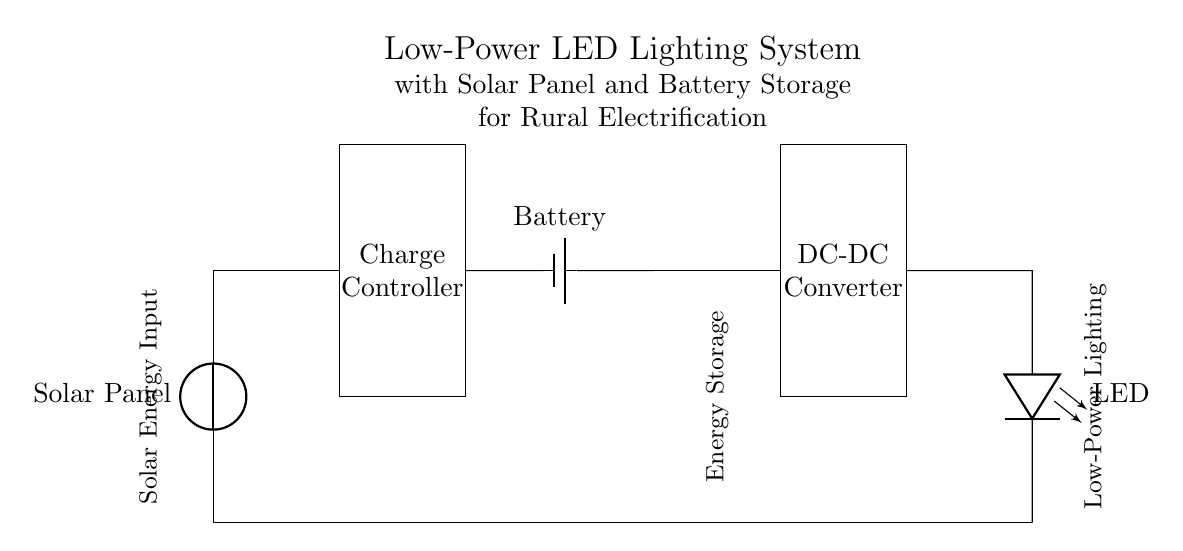What is the primary power source in this circuit? The primary power source in this circuit is the solar panel, which converts solar energy into electrical energy.
Answer: Solar Panel What component is responsible for energy storage? The component responsible for energy storage is the battery, which stores electrical energy generated by the solar panel for later use.
Answer: Battery What type of lighting is used in this system? The type of lighting used in this system is LED, which is energy-efficient and low-power.
Answer: LED How many main components are in the circuit? There are four main components in the circuit: the solar panel, charge controller, battery, and LED.
Answer: Four What functionality does the charge controller provide? The charge controller regulates the voltage and current coming from the solar panel to prevent overcharging the battery and ensure safe operation.
Answer: Regulation How does the DC-DC converter contribute to the circuit? The DC-DC converter adjusts the voltage from the battery to the appropriate level required by the LED, ensuring optimal performance and efficiency.
Answer: Voltage adjustment What is the general flow of energy in this system? The flow of energy starts at the solar panel, which generates electricity, then passes through the charge controller to the battery for storage, and finally powers the LED through the DC-DC converter.
Answer: Solar to battery to LED 